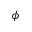Convert formula to latex. <formula><loc_0><loc_0><loc_500><loc_500>\boldsymbol \phi</formula> 